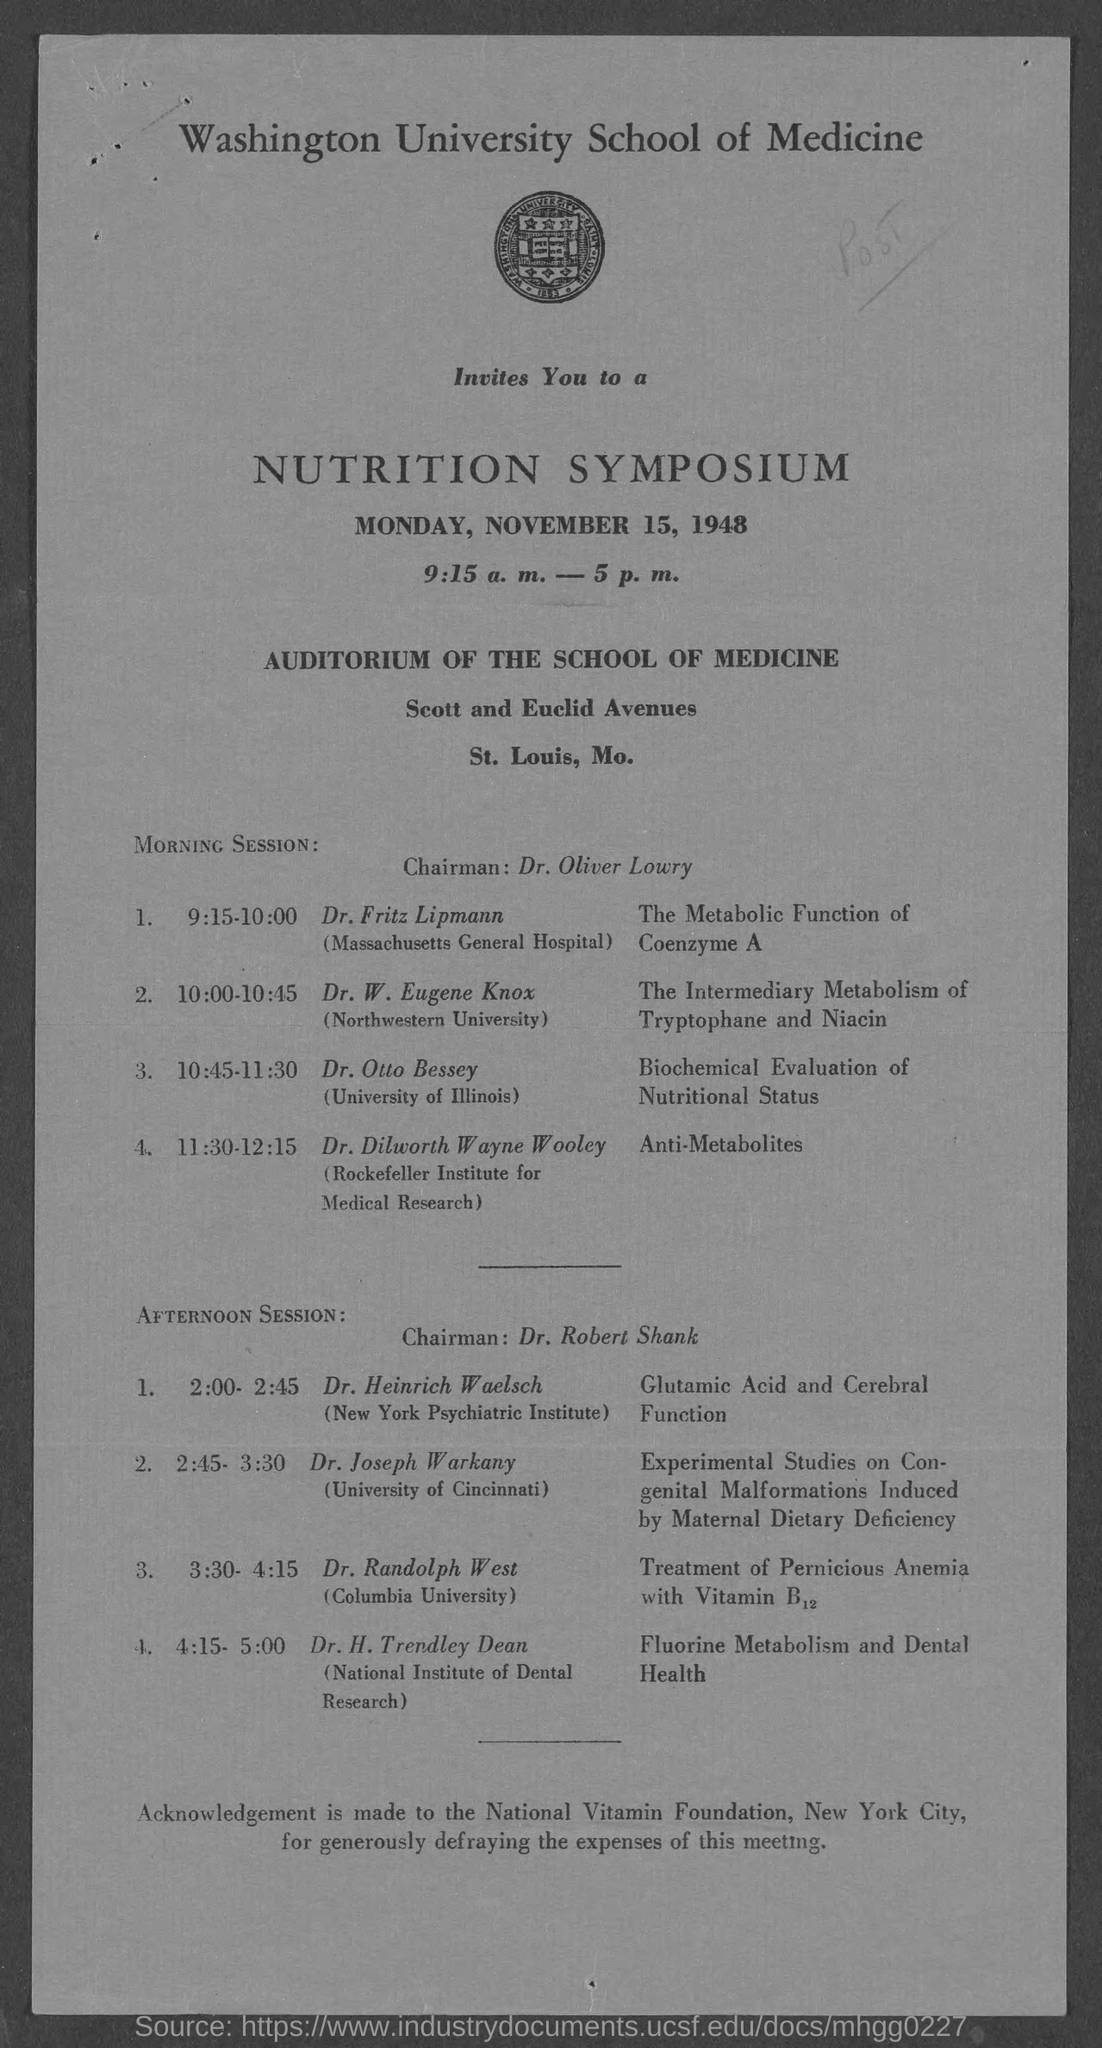Who is the chairman for morning session ?
Make the answer very short. Dr. Oliver Lowry. Who is the chairman for afternoon session ?
Make the answer very short. Dr. Robert Shank. On what day of the week is symposium held on?
Your response must be concise. Monday. On what date is the symposium  held on?
Your answer should be compact. November 15, 1948. To which university does Dr. Otto Bessey belong to?
Offer a very short reply. University of Illinois. To which university does dr. w. eugene knox belong to?
Your answer should be very brief. Northwestern University. To which university does dr.joseph warkany belong to ?
Your answer should be very brief. University of Cincinnati. To which university does dr. randolph west belong to ?
Your answer should be very brief. Columbia University. To which institute does dr. heinrich waelsch belong to ?
Your response must be concise. New York Psychiatric Institute. 